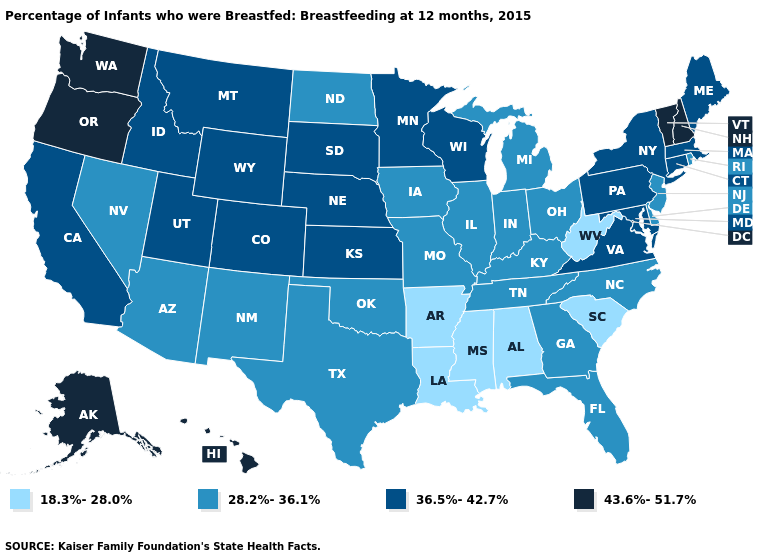Does the map have missing data?
Quick response, please. No. Among the states that border Wyoming , which have the lowest value?
Give a very brief answer. Colorado, Idaho, Montana, Nebraska, South Dakota, Utah. Name the states that have a value in the range 18.3%-28.0%?
Quick response, please. Alabama, Arkansas, Louisiana, Mississippi, South Carolina, West Virginia. Name the states that have a value in the range 18.3%-28.0%?
Be succinct. Alabama, Arkansas, Louisiana, Mississippi, South Carolina, West Virginia. What is the value of Montana?
Keep it brief. 36.5%-42.7%. Does New Jersey have the lowest value in the Northeast?
Quick response, please. Yes. Does the map have missing data?
Short answer required. No. Which states have the lowest value in the West?
Short answer required. Arizona, Nevada, New Mexico. Name the states that have a value in the range 43.6%-51.7%?
Concise answer only. Alaska, Hawaii, New Hampshire, Oregon, Vermont, Washington. What is the highest value in states that border Kansas?
Give a very brief answer. 36.5%-42.7%. Name the states that have a value in the range 18.3%-28.0%?
Write a very short answer. Alabama, Arkansas, Louisiana, Mississippi, South Carolina, West Virginia. How many symbols are there in the legend?
Answer briefly. 4. What is the lowest value in the USA?
Answer briefly. 18.3%-28.0%. Which states have the lowest value in the South?
Write a very short answer. Alabama, Arkansas, Louisiana, Mississippi, South Carolina, West Virginia. Does Alabama have the highest value in the USA?
Quick response, please. No. 